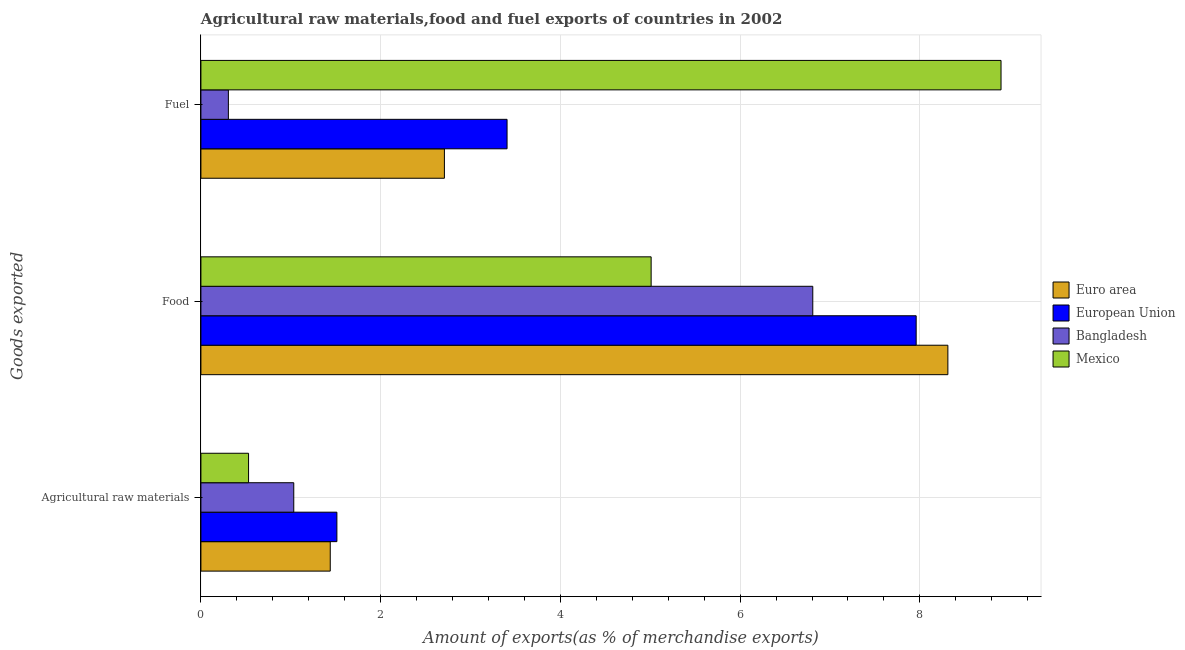How many different coloured bars are there?
Provide a succinct answer. 4. How many groups of bars are there?
Give a very brief answer. 3. Are the number of bars per tick equal to the number of legend labels?
Offer a terse response. Yes. Are the number of bars on each tick of the Y-axis equal?
Your answer should be very brief. Yes. How many bars are there on the 2nd tick from the top?
Your response must be concise. 4. How many bars are there on the 1st tick from the bottom?
Give a very brief answer. 4. What is the label of the 1st group of bars from the top?
Provide a succinct answer. Fuel. What is the percentage of fuel exports in Euro area?
Offer a very short reply. 2.71. Across all countries, what is the maximum percentage of fuel exports?
Offer a very short reply. 8.9. Across all countries, what is the minimum percentage of raw materials exports?
Keep it short and to the point. 0.53. In which country was the percentage of food exports minimum?
Offer a terse response. Mexico. What is the total percentage of food exports in the graph?
Make the answer very short. 28.09. What is the difference between the percentage of food exports in Bangladesh and that in European Union?
Your response must be concise. -1.15. What is the difference between the percentage of raw materials exports in Bangladesh and the percentage of fuel exports in Euro area?
Give a very brief answer. -1.68. What is the average percentage of fuel exports per country?
Give a very brief answer. 3.83. What is the difference between the percentage of fuel exports and percentage of raw materials exports in European Union?
Provide a short and direct response. 1.89. In how many countries, is the percentage of raw materials exports greater than 1.6 %?
Your answer should be compact. 0. What is the ratio of the percentage of raw materials exports in Euro area to that in Bangladesh?
Keep it short and to the point. 1.39. Is the percentage of fuel exports in European Union less than that in Euro area?
Offer a terse response. No. What is the difference between the highest and the second highest percentage of raw materials exports?
Keep it short and to the point. 0.07. What is the difference between the highest and the lowest percentage of fuel exports?
Your answer should be compact. 8.6. In how many countries, is the percentage of fuel exports greater than the average percentage of fuel exports taken over all countries?
Give a very brief answer. 1. Is the sum of the percentage of fuel exports in Mexico and Euro area greater than the maximum percentage of raw materials exports across all countries?
Provide a succinct answer. Yes. How many bars are there?
Provide a succinct answer. 12. Are all the bars in the graph horizontal?
Ensure brevity in your answer.  Yes. How many countries are there in the graph?
Provide a succinct answer. 4. Are the values on the major ticks of X-axis written in scientific E-notation?
Offer a terse response. No. Does the graph contain any zero values?
Offer a very short reply. No. Where does the legend appear in the graph?
Your answer should be very brief. Center right. How are the legend labels stacked?
Keep it short and to the point. Vertical. What is the title of the graph?
Provide a succinct answer. Agricultural raw materials,food and fuel exports of countries in 2002. What is the label or title of the X-axis?
Ensure brevity in your answer.  Amount of exports(as % of merchandise exports). What is the label or title of the Y-axis?
Make the answer very short. Goods exported. What is the Amount of exports(as % of merchandise exports) of Euro area in Agricultural raw materials?
Keep it short and to the point. 1.44. What is the Amount of exports(as % of merchandise exports) of European Union in Agricultural raw materials?
Give a very brief answer. 1.51. What is the Amount of exports(as % of merchandise exports) of Bangladesh in Agricultural raw materials?
Keep it short and to the point. 1.03. What is the Amount of exports(as % of merchandise exports) of Mexico in Agricultural raw materials?
Provide a succinct answer. 0.53. What is the Amount of exports(as % of merchandise exports) of Euro area in Food?
Offer a terse response. 8.31. What is the Amount of exports(as % of merchandise exports) of European Union in Food?
Make the answer very short. 7.96. What is the Amount of exports(as % of merchandise exports) of Bangladesh in Food?
Provide a short and direct response. 6.81. What is the Amount of exports(as % of merchandise exports) of Mexico in Food?
Ensure brevity in your answer.  5.01. What is the Amount of exports(as % of merchandise exports) of Euro area in Fuel?
Offer a terse response. 2.71. What is the Amount of exports(as % of merchandise exports) of European Union in Fuel?
Your answer should be very brief. 3.41. What is the Amount of exports(as % of merchandise exports) in Bangladesh in Fuel?
Provide a short and direct response. 0.31. What is the Amount of exports(as % of merchandise exports) of Mexico in Fuel?
Offer a very short reply. 8.9. Across all Goods exported, what is the maximum Amount of exports(as % of merchandise exports) in Euro area?
Give a very brief answer. 8.31. Across all Goods exported, what is the maximum Amount of exports(as % of merchandise exports) in European Union?
Provide a succinct answer. 7.96. Across all Goods exported, what is the maximum Amount of exports(as % of merchandise exports) in Bangladesh?
Your answer should be very brief. 6.81. Across all Goods exported, what is the maximum Amount of exports(as % of merchandise exports) in Mexico?
Make the answer very short. 8.9. Across all Goods exported, what is the minimum Amount of exports(as % of merchandise exports) of Euro area?
Your answer should be compact. 1.44. Across all Goods exported, what is the minimum Amount of exports(as % of merchandise exports) in European Union?
Your answer should be very brief. 1.51. Across all Goods exported, what is the minimum Amount of exports(as % of merchandise exports) of Bangladesh?
Provide a succinct answer. 0.31. Across all Goods exported, what is the minimum Amount of exports(as % of merchandise exports) in Mexico?
Offer a very short reply. 0.53. What is the total Amount of exports(as % of merchandise exports) in Euro area in the graph?
Offer a very short reply. 12.46. What is the total Amount of exports(as % of merchandise exports) in European Union in the graph?
Your response must be concise. 12.88. What is the total Amount of exports(as % of merchandise exports) of Bangladesh in the graph?
Offer a terse response. 8.15. What is the total Amount of exports(as % of merchandise exports) in Mexico in the graph?
Ensure brevity in your answer.  14.44. What is the difference between the Amount of exports(as % of merchandise exports) of Euro area in Agricultural raw materials and that in Food?
Offer a terse response. -6.87. What is the difference between the Amount of exports(as % of merchandise exports) in European Union in Agricultural raw materials and that in Food?
Offer a terse response. -6.45. What is the difference between the Amount of exports(as % of merchandise exports) in Bangladesh in Agricultural raw materials and that in Food?
Give a very brief answer. -5.78. What is the difference between the Amount of exports(as % of merchandise exports) in Mexico in Agricultural raw materials and that in Food?
Your answer should be very brief. -4.48. What is the difference between the Amount of exports(as % of merchandise exports) of Euro area in Agricultural raw materials and that in Fuel?
Offer a very short reply. -1.27. What is the difference between the Amount of exports(as % of merchandise exports) of European Union in Agricultural raw materials and that in Fuel?
Your response must be concise. -1.89. What is the difference between the Amount of exports(as % of merchandise exports) in Bangladesh in Agricultural raw materials and that in Fuel?
Offer a terse response. 0.73. What is the difference between the Amount of exports(as % of merchandise exports) in Mexico in Agricultural raw materials and that in Fuel?
Provide a short and direct response. -8.37. What is the difference between the Amount of exports(as % of merchandise exports) in Euro area in Food and that in Fuel?
Offer a very short reply. 5.6. What is the difference between the Amount of exports(as % of merchandise exports) of European Union in Food and that in Fuel?
Offer a terse response. 4.55. What is the difference between the Amount of exports(as % of merchandise exports) of Bangladesh in Food and that in Fuel?
Offer a terse response. 6.5. What is the difference between the Amount of exports(as % of merchandise exports) of Mexico in Food and that in Fuel?
Make the answer very short. -3.89. What is the difference between the Amount of exports(as % of merchandise exports) in Euro area in Agricultural raw materials and the Amount of exports(as % of merchandise exports) in European Union in Food?
Your answer should be compact. -6.52. What is the difference between the Amount of exports(as % of merchandise exports) of Euro area in Agricultural raw materials and the Amount of exports(as % of merchandise exports) of Bangladesh in Food?
Offer a terse response. -5.37. What is the difference between the Amount of exports(as % of merchandise exports) of Euro area in Agricultural raw materials and the Amount of exports(as % of merchandise exports) of Mexico in Food?
Offer a terse response. -3.57. What is the difference between the Amount of exports(as % of merchandise exports) in European Union in Agricultural raw materials and the Amount of exports(as % of merchandise exports) in Bangladesh in Food?
Your answer should be very brief. -5.3. What is the difference between the Amount of exports(as % of merchandise exports) of European Union in Agricultural raw materials and the Amount of exports(as % of merchandise exports) of Mexico in Food?
Offer a very short reply. -3.5. What is the difference between the Amount of exports(as % of merchandise exports) of Bangladesh in Agricultural raw materials and the Amount of exports(as % of merchandise exports) of Mexico in Food?
Provide a succinct answer. -3.98. What is the difference between the Amount of exports(as % of merchandise exports) of Euro area in Agricultural raw materials and the Amount of exports(as % of merchandise exports) of European Union in Fuel?
Ensure brevity in your answer.  -1.97. What is the difference between the Amount of exports(as % of merchandise exports) in Euro area in Agricultural raw materials and the Amount of exports(as % of merchandise exports) in Bangladesh in Fuel?
Keep it short and to the point. 1.13. What is the difference between the Amount of exports(as % of merchandise exports) in Euro area in Agricultural raw materials and the Amount of exports(as % of merchandise exports) in Mexico in Fuel?
Your answer should be very brief. -7.46. What is the difference between the Amount of exports(as % of merchandise exports) in European Union in Agricultural raw materials and the Amount of exports(as % of merchandise exports) in Bangladesh in Fuel?
Offer a terse response. 1.21. What is the difference between the Amount of exports(as % of merchandise exports) of European Union in Agricultural raw materials and the Amount of exports(as % of merchandise exports) of Mexico in Fuel?
Provide a succinct answer. -7.39. What is the difference between the Amount of exports(as % of merchandise exports) in Bangladesh in Agricultural raw materials and the Amount of exports(as % of merchandise exports) in Mexico in Fuel?
Keep it short and to the point. -7.87. What is the difference between the Amount of exports(as % of merchandise exports) in Euro area in Food and the Amount of exports(as % of merchandise exports) in European Union in Fuel?
Keep it short and to the point. 4.91. What is the difference between the Amount of exports(as % of merchandise exports) of Euro area in Food and the Amount of exports(as % of merchandise exports) of Bangladesh in Fuel?
Provide a succinct answer. 8.01. What is the difference between the Amount of exports(as % of merchandise exports) in Euro area in Food and the Amount of exports(as % of merchandise exports) in Mexico in Fuel?
Provide a succinct answer. -0.59. What is the difference between the Amount of exports(as % of merchandise exports) of European Union in Food and the Amount of exports(as % of merchandise exports) of Bangladesh in Fuel?
Make the answer very short. 7.65. What is the difference between the Amount of exports(as % of merchandise exports) in European Union in Food and the Amount of exports(as % of merchandise exports) in Mexico in Fuel?
Give a very brief answer. -0.94. What is the difference between the Amount of exports(as % of merchandise exports) of Bangladesh in Food and the Amount of exports(as % of merchandise exports) of Mexico in Fuel?
Provide a succinct answer. -2.09. What is the average Amount of exports(as % of merchandise exports) of Euro area per Goods exported?
Your response must be concise. 4.15. What is the average Amount of exports(as % of merchandise exports) in European Union per Goods exported?
Give a very brief answer. 4.29. What is the average Amount of exports(as % of merchandise exports) of Bangladesh per Goods exported?
Offer a very short reply. 2.72. What is the average Amount of exports(as % of merchandise exports) of Mexico per Goods exported?
Offer a terse response. 4.81. What is the difference between the Amount of exports(as % of merchandise exports) in Euro area and Amount of exports(as % of merchandise exports) in European Union in Agricultural raw materials?
Your answer should be very brief. -0.07. What is the difference between the Amount of exports(as % of merchandise exports) of Euro area and Amount of exports(as % of merchandise exports) of Bangladesh in Agricultural raw materials?
Ensure brevity in your answer.  0.41. What is the difference between the Amount of exports(as % of merchandise exports) of Euro area and Amount of exports(as % of merchandise exports) of Mexico in Agricultural raw materials?
Make the answer very short. 0.91. What is the difference between the Amount of exports(as % of merchandise exports) in European Union and Amount of exports(as % of merchandise exports) in Bangladesh in Agricultural raw materials?
Keep it short and to the point. 0.48. What is the difference between the Amount of exports(as % of merchandise exports) in European Union and Amount of exports(as % of merchandise exports) in Mexico in Agricultural raw materials?
Offer a very short reply. 0.98. What is the difference between the Amount of exports(as % of merchandise exports) of Bangladesh and Amount of exports(as % of merchandise exports) of Mexico in Agricultural raw materials?
Make the answer very short. 0.5. What is the difference between the Amount of exports(as % of merchandise exports) in Euro area and Amount of exports(as % of merchandise exports) in European Union in Food?
Your answer should be compact. 0.35. What is the difference between the Amount of exports(as % of merchandise exports) in Euro area and Amount of exports(as % of merchandise exports) in Bangladesh in Food?
Give a very brief answer. 1.5. What is the difference between the Amount of exports(as % of merchandise exports) of Euro area and Amount of exports(as % of merchandise exports) of Mexico in Food?
Offer a very short reply. 3.3. What is the difference between the Amount of exports(as % of merchandise exports) of European Union and Amount of exports(as % of merchandise exports) of Bangladesh in Food?
Keep it short and to the point. 1.15. What is the difference between the Amount of exports(as % of merchandise exports) of European Union and Amount of exports(as % of merchandise exports) of Mexico in Food?
Provide a succinct answer. 2.95. What is the difference between the Amount of exports(as % of merchandise exports) of Bangladesh and Amount of exports(as % of merchandise exports) of Mexico in Food?
Keep it short and to the point. 1.8. What is the difference between the Amount of exports(as % of merchandise exports) in Euro area and Amount of exports(as % of merchandise exports) in European Union in Fuel?
Keep it short and to the point. -0.7. What is the difference between the Amount of exports(as % of merchandise exports) in Euro area and Amount of exports(as % of merchandise exports) in Bangladesh in Fuel?
Make the answer very short. 2.4. What is the difference between the Amount of exports(as % of merchandise exports) in Euro area and Amount of exports(as % of merchandise exports) in Mexico in Fuel?
Your answer should be very brief. -6.19. What is the difference between the Amount of exports(as % of merchandise exports) of European Union and Amount of exports(as % of merchandise exports) of Bangladesh in Fuel?
Make the answer very short. 3.1. What is the difference between the Amount of exports(as % of merchandise exports) in European Union and Amount of exports(as % of merchandise exports) in Mexico in Fuel?
Your answer should be compact. -5.5. What is the difference between the Amount of exports(as % of merchandise exports) of Bangladesh and Amount of exports(as % of merchandise exports) of Mexico in Fuel?
Provide a succinct answer. -8.6. What is the ratio of the Amount of exports(as % of merchandise exports) in Euro area in Agricultural raw materials to that in Food?
Provide a short and direct response. 0.17. What is the ratio of the Amount of exports(as % of merchandise exports) of European Union in Agricultural raw materials to that in Food?
Ensure brevity in your answer.  0.19. What is the ratio of the Amount of exports(as % of merchandise exports) in Bangladesh in Agricultural raw materials to that in Food?
Offer a terse response. 0.15. What is the ratio of the Amount of exports(as % of merchandise exports) of Mexico in Agricultural raw materials to that in Food?
Offer a very short reply. 0.11. What is the ratio of the Amount of exports(as % of merchandise exports) in Euro area in Agricultural raw materials to that in Fuel?
Your answer should be compact. 0.53. What is the ratio of the Amount of exports(as % of merchandise exports) of European Union in Agricultural raw materials to that in Fuel?
Make the answer very short. 0.44. What is the ratio of the Amount of exports(as % of merchandise exports) in Bangladesh in Agricultural raw materials to that in Fuel?
Your response must be concise. 3.38. What is the ratio of the Amount of exports(as % of merchandise exports) in Mexico in Agricultural raw materials to that in Fuel?
Provide a succinct answer. 0.06. What is the ratio of the Amount of exports(as % of merchandise exports) of Euro area in Food to that in Fuel?
Provide a succinct answer. 3.07. What is the ratio of the Amount of exports(as % of merchandise exports) of European Union in Food to that in Fuel?
Offer a very short reply. 2.34. What is the ratio of the Amount of exports(as % of merchandise exports) in Bangladesh in Food to that in Fuel?
Offer a terse response. 22.29. What is the ratio of the Amount of exports(as % of merchandise exports) of Mexico in Food to that in Fuel?
Your answer should be compact. 0.56. What is the difference between the highest and the second highest Amount of exports(as % of merchandise exports) of Euro area?
Provide a short and direct response. 5.6. What is the difference between the highest and the second highest Amount of exports(as % of merchandise exports) in European Union?
Make the answer very short. 4.55. What is the difference between the highest and the second highest Amount of exports(as % of merchandise exports) of Bangladesh?
Ensure brevity in your answer.  5.78. What is the difference between the highest and the second highest Amount of exports(as % of merchandise exports) of Mexico?
Offer a very short reply. 3.89. What is the difference between the highest and the lowest Amount of exports(as % of merchandise exports) in Euro area?
Offer a very short reply. 6.87. What is the difference between the highest and the lowest Amount of exports(as % of merchandise exports) in European Union?
Your answer should be very brief. 6.45. What is the difference between the highest and the lowest Amount of exports(as % of merchandise exports) of Bangladesh?
Keep it short and to the point. 6.5. What is the difference between the highest and the lowest Amount of exports(as % of merchandise exports) of Mexico?
Make the answer very short. 8.37. 